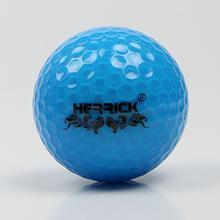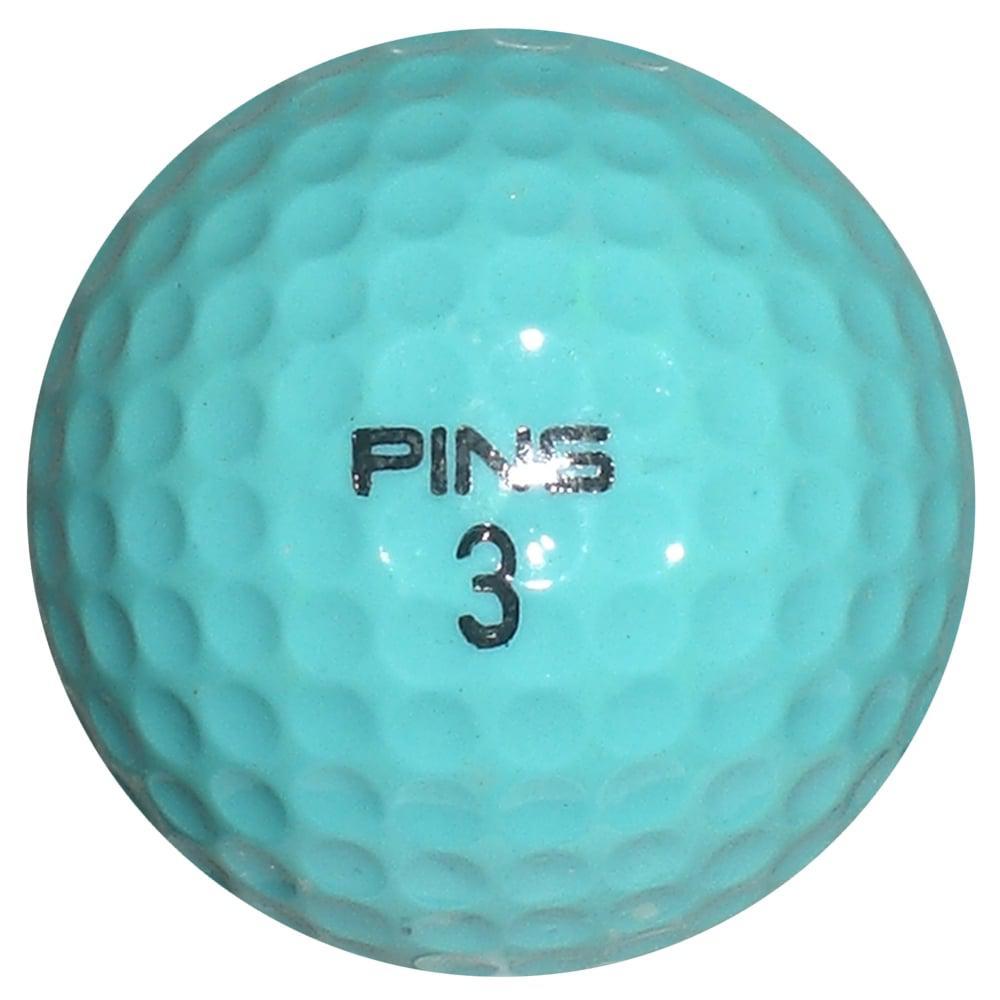The first image is the image on the left, the second image is the image on the right. Considering the images on both sides, is "An image shows a golf ball bisected vertically, with its blue interior showing on the right side of the ball." valid? Answer yes or no. No. The first image is the image on the left, the second image is the image on the right. For the images shown, is this caption "One of the balls is two different colors." true? Answer yes or no. No. 